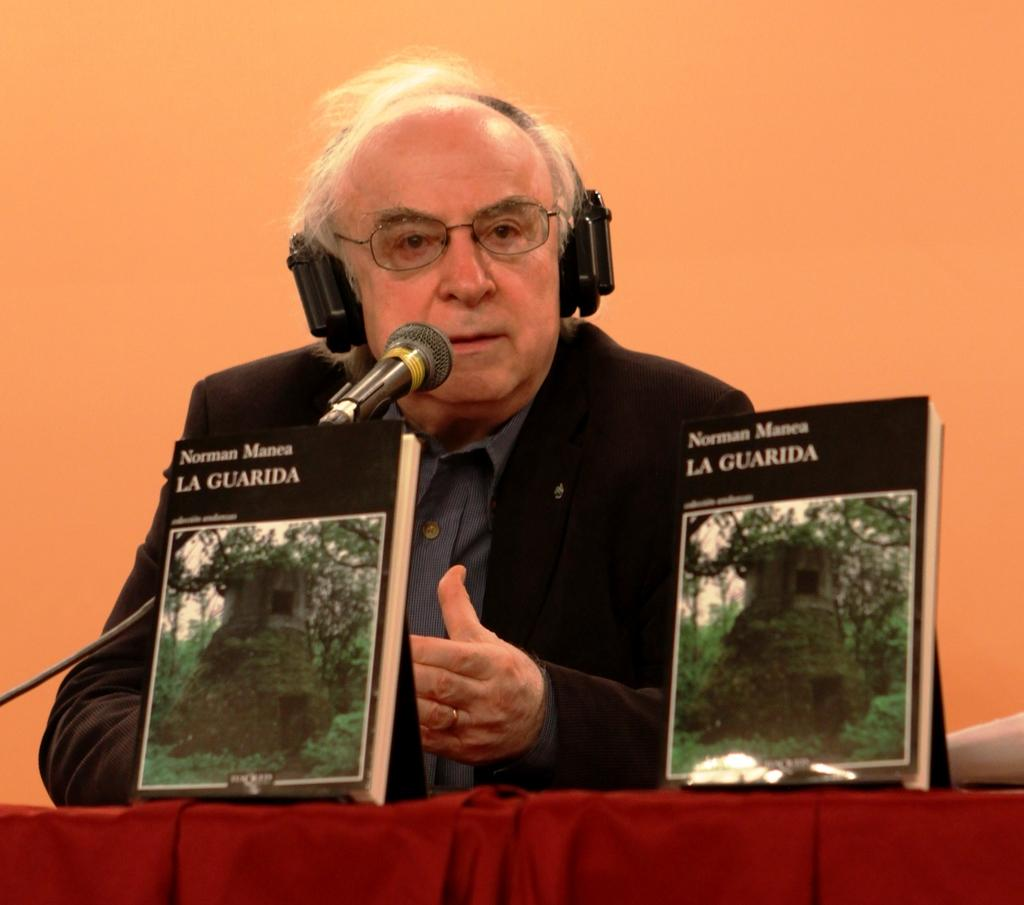What is the person in the image doing? The person is standing at the table. What can be seen on the person's head? The person is wearing a headset. What items are on the table besides the person? There are books and a microphone (mic) on the table. What is visible in the background of the image? There is a wall in the background. How many clocks are present on the table in the image? There are no clocks visible on the table in the image. 